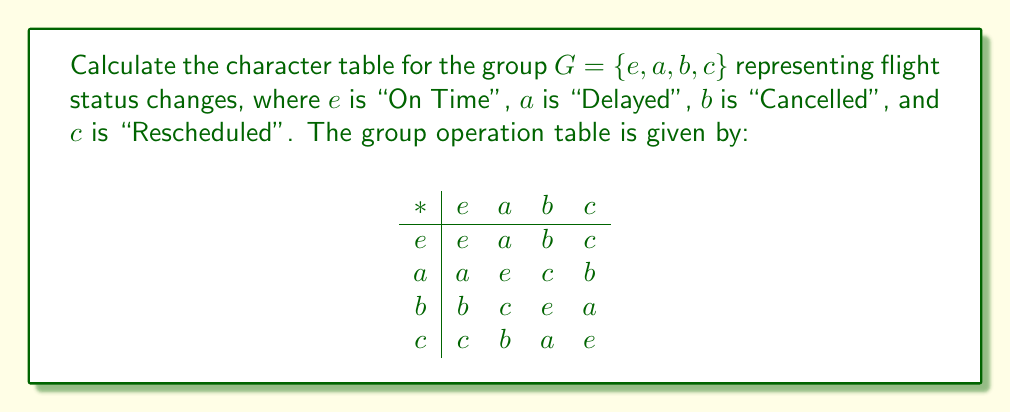Can you solve this math problem? To calculate the character table for this group, we'll follow these steps:

1) First, identify the conjugacy classes:
   $[e] = \{e\}$
   $[a] = \{a\}$
   $[b] = \{b\}$
   $[c] = \{c\}$
   Each element forms its own conjugacy class as the group is abelian.

2) The number of irreducible representations equals the number of conjugacy classes, which is 4.

3) For an abelian group, all irreducible representations are 1-dimensional, and the characters are the same as the representations.

4) The first row of the character table always corresponds to the trivial representation, where all elements map to 1.

5) For the remaining rows, we need to find homomorphisms from $G$ to $\mathbb{C}^*$. Let $\omega = e^{2\pi i/4} = i$ be a primitive 4th root of unity.

6) The characters are:
   $\chi_1(g) = 1$ for all $g \in G$
   $\chi_2(e) = 1, \chi_2(a) = -1, \chi_2(b) = 1, \chi_2(c) = -1$
   $\chi_3(e) = 1, \chi_3(a) = i, \chi_3(b) = -1, \chi_3(c) = -i$
   $\chi_4(e) = 1, \chi_4(a) = -i, \chi_4(b) = -1, \chi_4(c) = i$

7) The character table is:

$$
\begin{array}{c|cccc}
G & [e] & [a] & [b] & [c] \\
\hline
\chi_1 & 1 & 1 & 1 & 1 \\
\chi_2 & 1 & -1 & 1 & -1 \\
\chi_3 & 1 & i & -1 & -i \\
\chi_4 & 1 & -i & -1 & i
\end{array}
$$
Answer: $$
\begin{array}{c|cccc}
G & [e] & [a] & [b] & [c] \\
\hline
\chi_1 & 1 & 1 & 1 & 1 \\
\chi_2 & 1 & -1 & 1 & -1 \\
\chi_3 & 1 & i & -1 & -i \\
\chi_4 & 1 & -i & -1 & i
\end{array}
$$ 